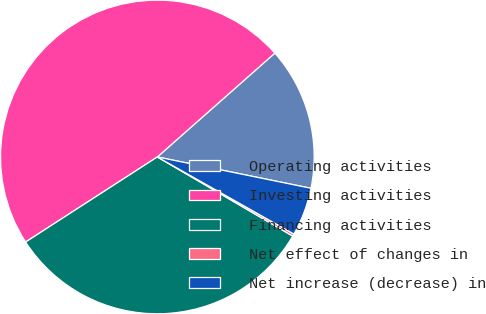<chart> <loc_0><loc_0><loc_500><loc_500><pie_chart><fcel>Operating activities<fcel>Investing activities<fcel>Financing activities<fcel>Net effect of changes in<fcel>Net increase (decrease) in<nl><fcel>14.72%<fcel>47.61%<fcel>32.45%<fcel>0.24%<fcel>4.98%<nl></chart> 